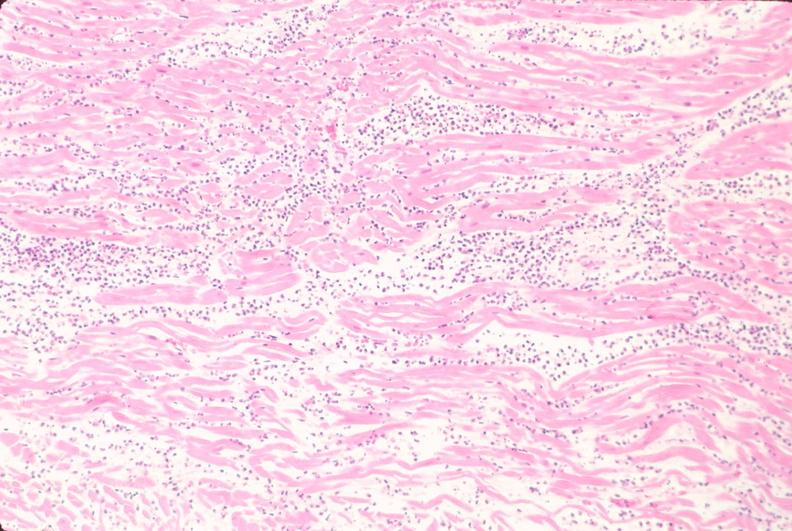where is this from?
Answer the question using a single word or phrase. Heart 